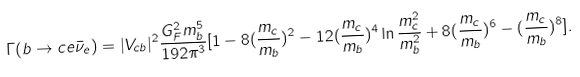<formula> <loc_0><loc_0><loc_500><loc_500>\Gamma ( b \rightarrow c e \bar { \nu } _ { e } ) = | V _ { c b } | ^ { 2 } \frac { G _ { F } ^ { 2 } m ^ { 5 } _ { b } } { 1 9 2 \pi ^ { 3 } } [ 1 - 8 ( \frac { m _ { c } } { m _ { b } } ) ^ { 2 } - 1 2 ( \frac { m _ { c } } { m _ { b } } ) ^ { 4 } \ln \frac { m ^ { 2 } _ { c } } { m ^ { 2 } _ { b } } + 8 ( \frac { m _ { c } } { m _ { b } } ) ^ { 6 } - ( \frac { m _ { c } } { m _ { b } } ) ^ { 8 } ] .</formula> 